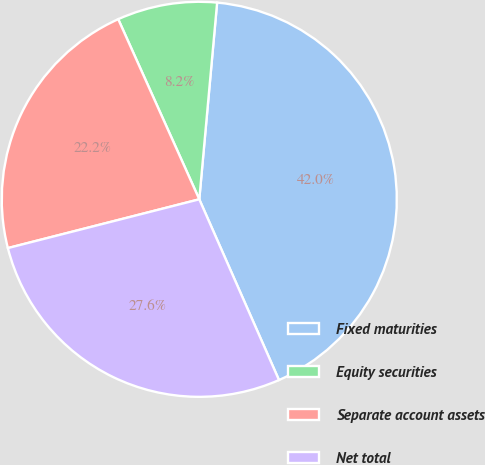Convert chart to OTSL. <chart><loc_0><loc_0><loc_500><loc_500><pie_chart><fcel>Fixed maturities<fcel>Equity securities<fcel>Separate account assets<fcel>Net total<nl><fcel>41.95%<fcel>8.17%<fcel>22.24%<fcel>27.64%<nl></chart> 